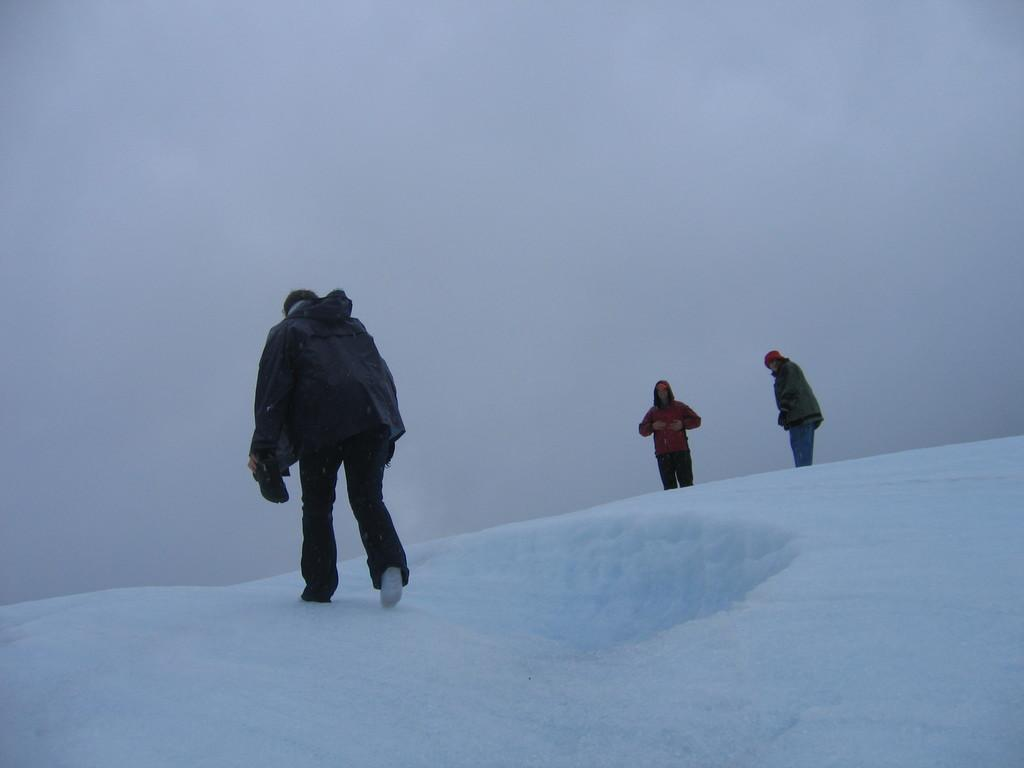What is the main subject of the image? There is a person walking on the snow in the foreground. How many people are in the image? There are people in the image. What can be seen in the background of the image? The background of the image appears to be the sky. What type of oven can be seen in the image? There is no oven present in the image. Is there a paper and pen visible in the image? There is no paper or pen visible in the image. 